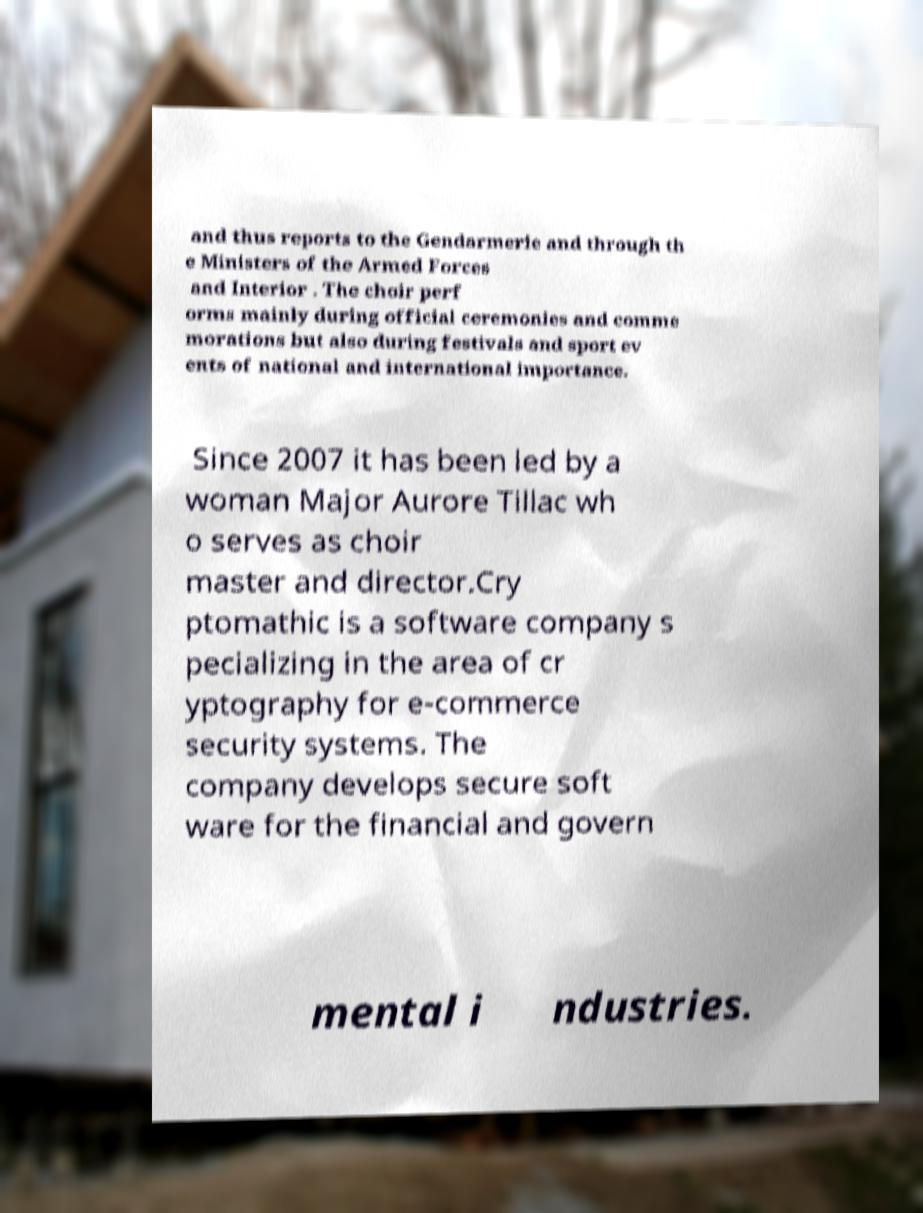There's text embedded in this image that I need extracted. Can you transcribe it verbatim? and thus reports to the Gendarmerie and through th e Ministers of the Armed Forces and Interior . The choir perf orms mainly during official ceremonies and comme morations but also during festivals and sport ev ents of national and international importance. Since 2007 it has been led by a woman Major Aurore Tillac wh o serves as choir master and director.Cry ptomathic is a software company s pecializing in the area of cr yptography for e-commerce security systems. The company develops secure soft ware for the financial and govern mental i ndustries. 